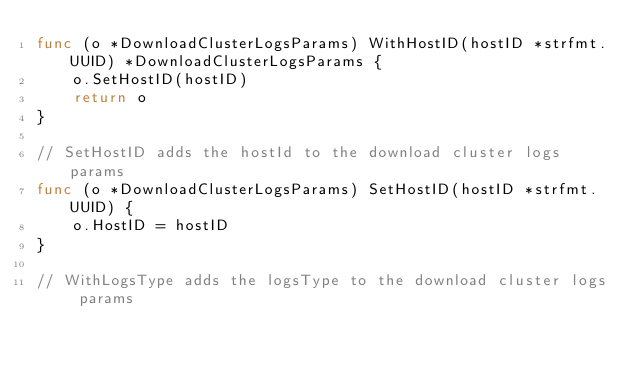Convert code to text. <code><loc_0><loc_0><loc_500><loc_500><_Go_>func (o *DownloadClusterLogsParams) WithHostID(hostID *strfmt.UUID) *DownloadClusterLogsParams {
	o.SetHostID(hostID)
	return o
}

// SetHostID adds the hostId to the download cluster logs params
func (o *DownloadClusterLogsParams) SetHostID(hostID *strfmt.UUID) {
	o.HostID = hostID
}

// WithLogsType adds the logsType to the download cluster logs params</code> 